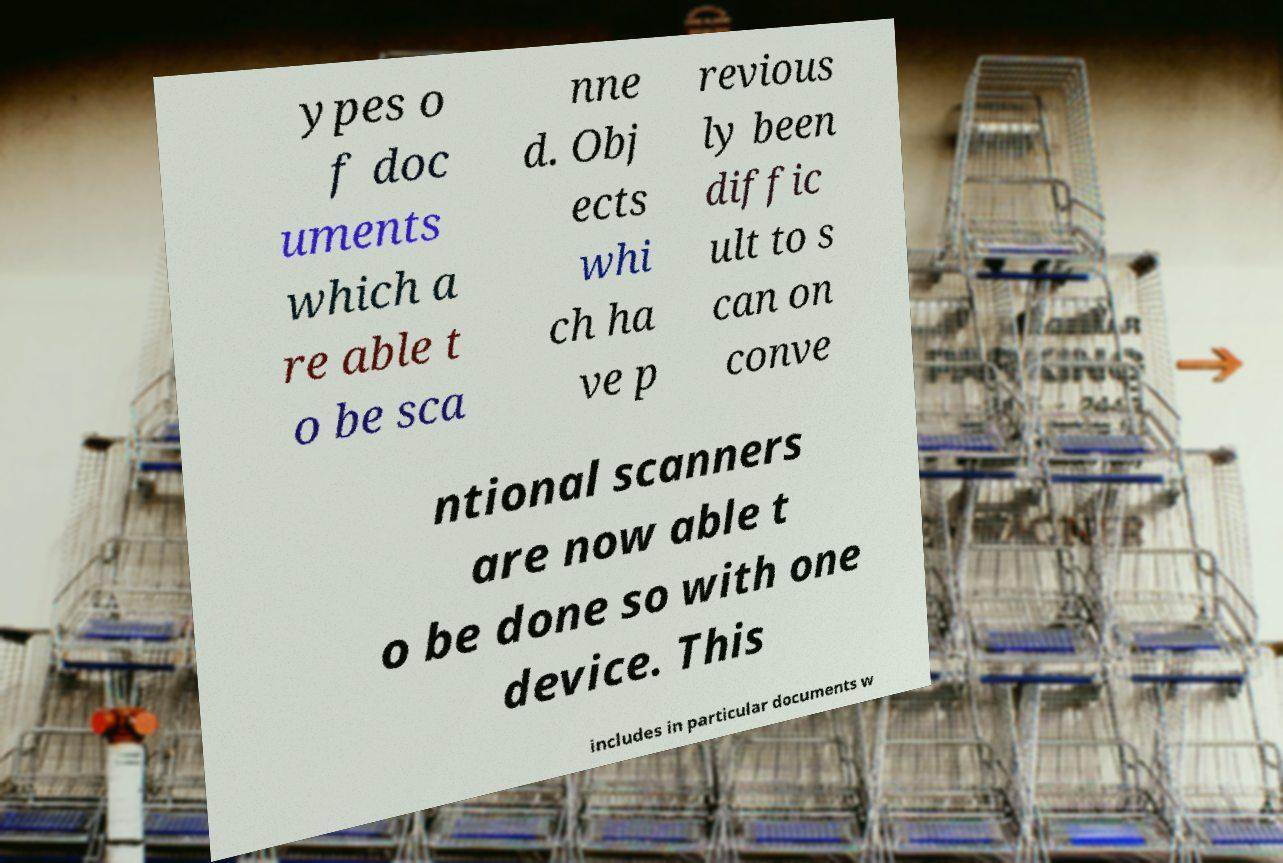I need the written content from this picture converted into text. Can you do that? ypes o f doc uments which a re able t o be sca nne d. Obj ects whi ch ha ve p revious ly been diffic ult to s can on conve ntional scanners are now able t o be done so with one device. This includes in particular documents w 